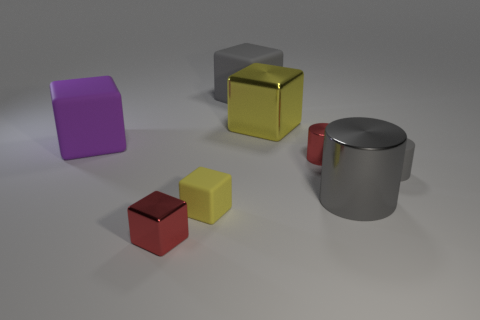How many things are gray matte cylinders right of the big yellow metal block or gray matte objects?
Your answer should be very brief. 2. Does the metallic thing to the left of the large gray block have the same color as the tiny metallic cylinder?
Offer a very short reply. Yes. There is a red object that is the same shape as the small yellow matte object; what is its size?
Give a very brief answer. Small. What is the color of the large cylinder that is on the right side of the small red thing that is on the right side of the metal block behind the small red block?
Your response must be concise. Gray. Is the red cube made of the same material as the large yellow cube?
Your answer should be very brief. Yes. Is there a gray cube behind the red shiny object that is behind the yellow block that is in front of the tiny gray matte cylinder?
Provide a short and direct response. Yes. Is the color of the tiny metal cylinder the same as the tiny shiny cube?
Your answer should be very brief. Yes. Are there fewer big gray rubber cylinders than small gray cylinders?
Your response must be concise. Yes. Is the yellow block that is in front of the small matte cylinder made of the same material as the big block that is to the left of the tiny matte block?
Make the answer very short. Yes. Is the number of yellow matte objects that are behind the purple matte block less than the number of tiny blue metal cylinders?
Offer a very short reply. No. 